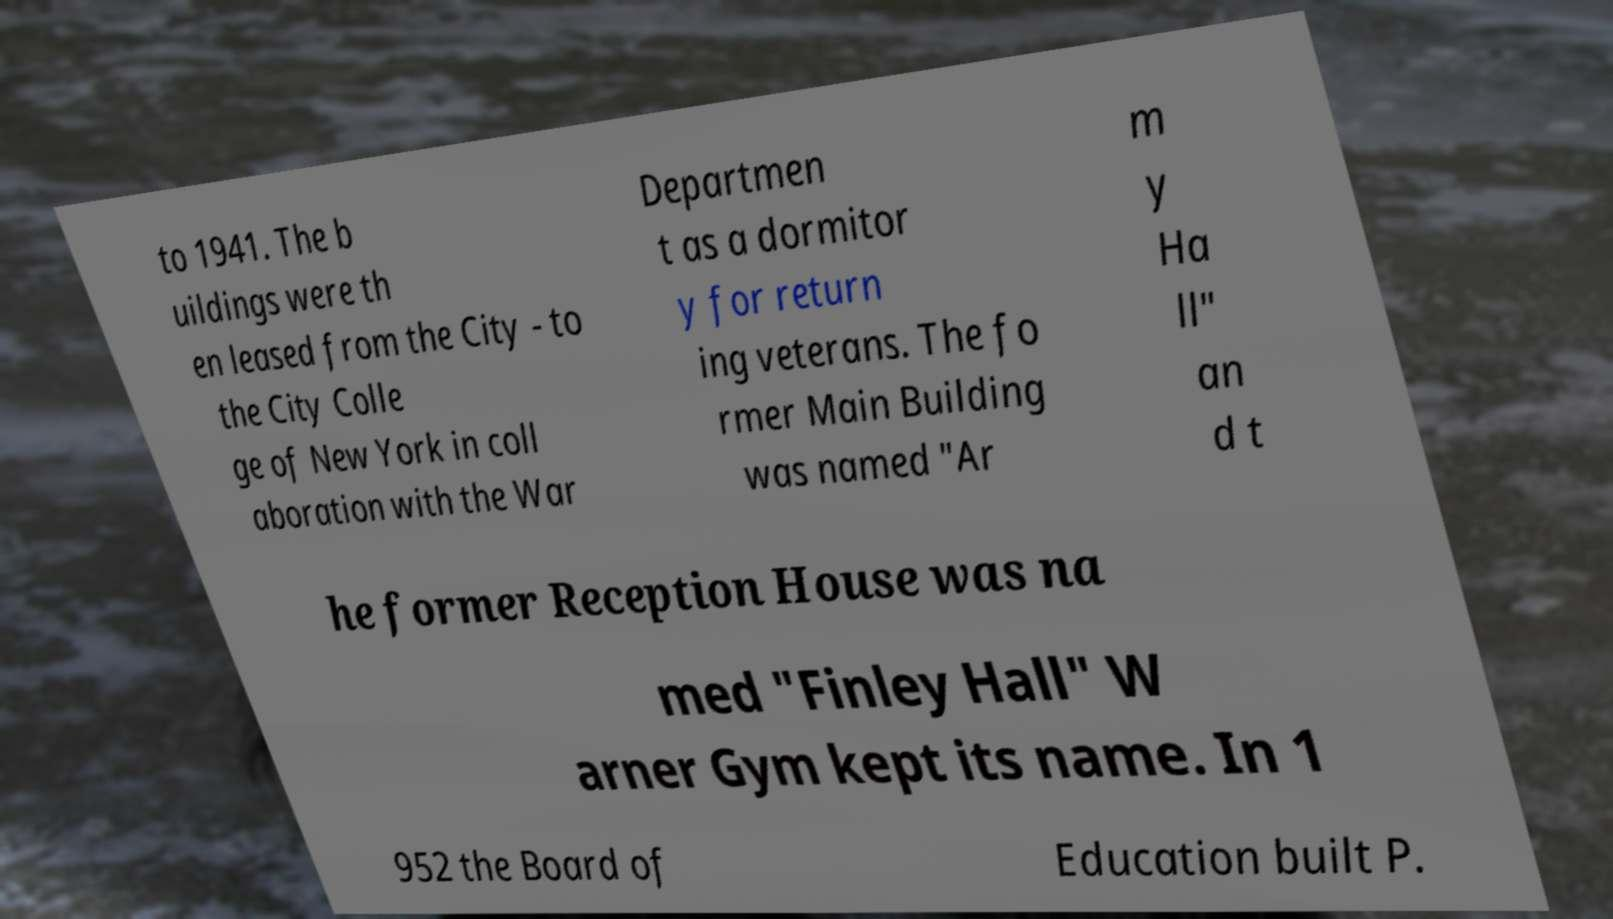Could you extract and type out the text from this image? to 1941. The b uildings were th en leased from the City - to the City Colle ge of New York in coll aboration with the War Departmen t as a dormitor y for return ing veterans. The fo rmer Main Building was named "Ar m y Ha ll" an d t he former Reception House was na med "Finley Hall" W arner Gym kept its name. In 1 952 the Board of Education built P. 